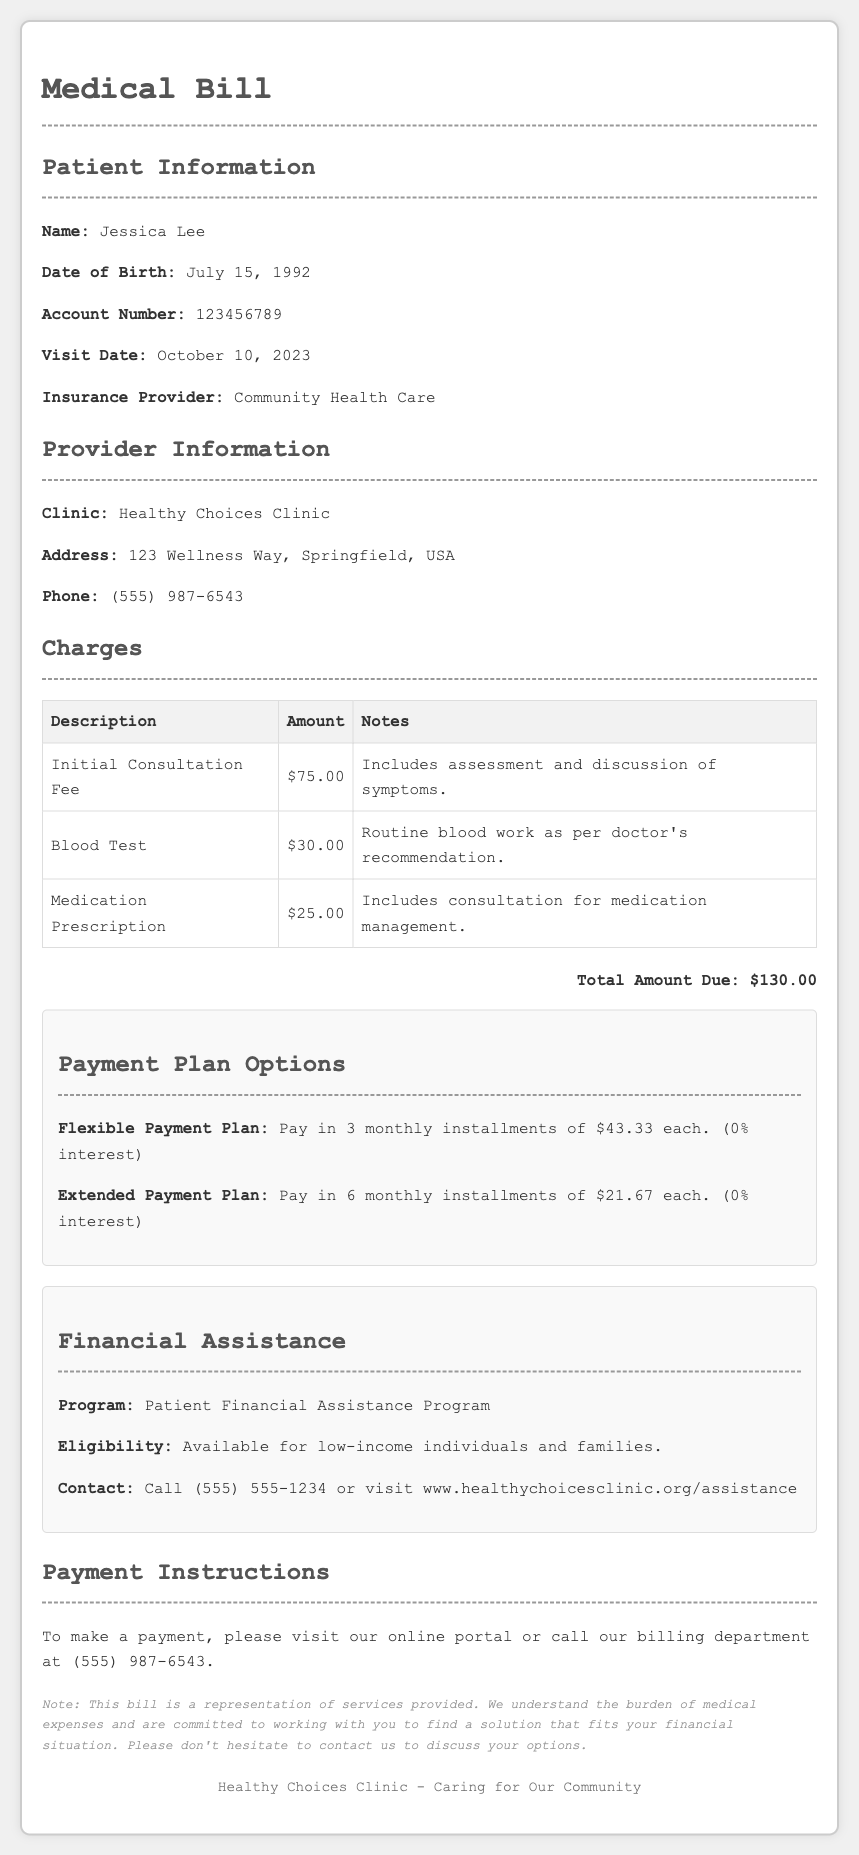What is the total amount due? The total amount due is stated prominently at the bottom of the charges section, which sums up all individual charges.
Answer: $130.00 Who is the patient? The patient's name is found in the patient information section at the top of the document.
Answer: Jessica Lee What is the phone number of the clinic? The clinic’s phone number is provided in the provider information section for easy contact.
Answer: (555) 987-6543 What is the eligibility for financial assistance? The eligibility criteria for financial assistance are mentioned in the financial assistance section.
Answer: Low-income individuals and families How many monthly installments are there in the flexible payment plan? The flexible payment plan details are listed under the payment plan options section; it specifies the number of installments.
Answer: 3 What type of program is available for financial assistance? The type of program is stated in the financial assistance section and refers to the specific assistance offered by the clinic.
Answer: Patient Financial Assistance Program When did the clinic visit occur? The visit date is detailed in the patient information section of the document.
Answer: October 10, 2023 What is included in the initial consultation fee? The notes next to the initial consultation fee outline what services are included within that charge.
Answer: Assessment and discussion of symptoms What is the address of the clinic? The address for the clinic is in the provider information section for location reference.
Answer: 123 Wellness Way, Springfield, USA 